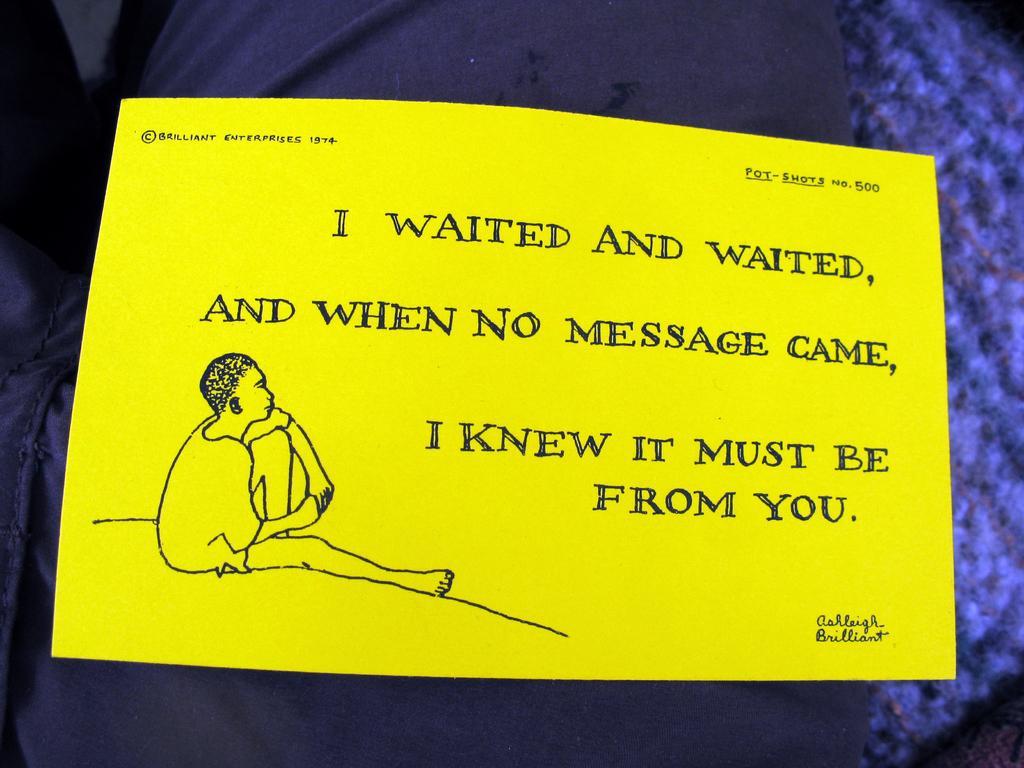Describe this image in one or two sentences. In this image we can see a yellow color note and some text written on it. 